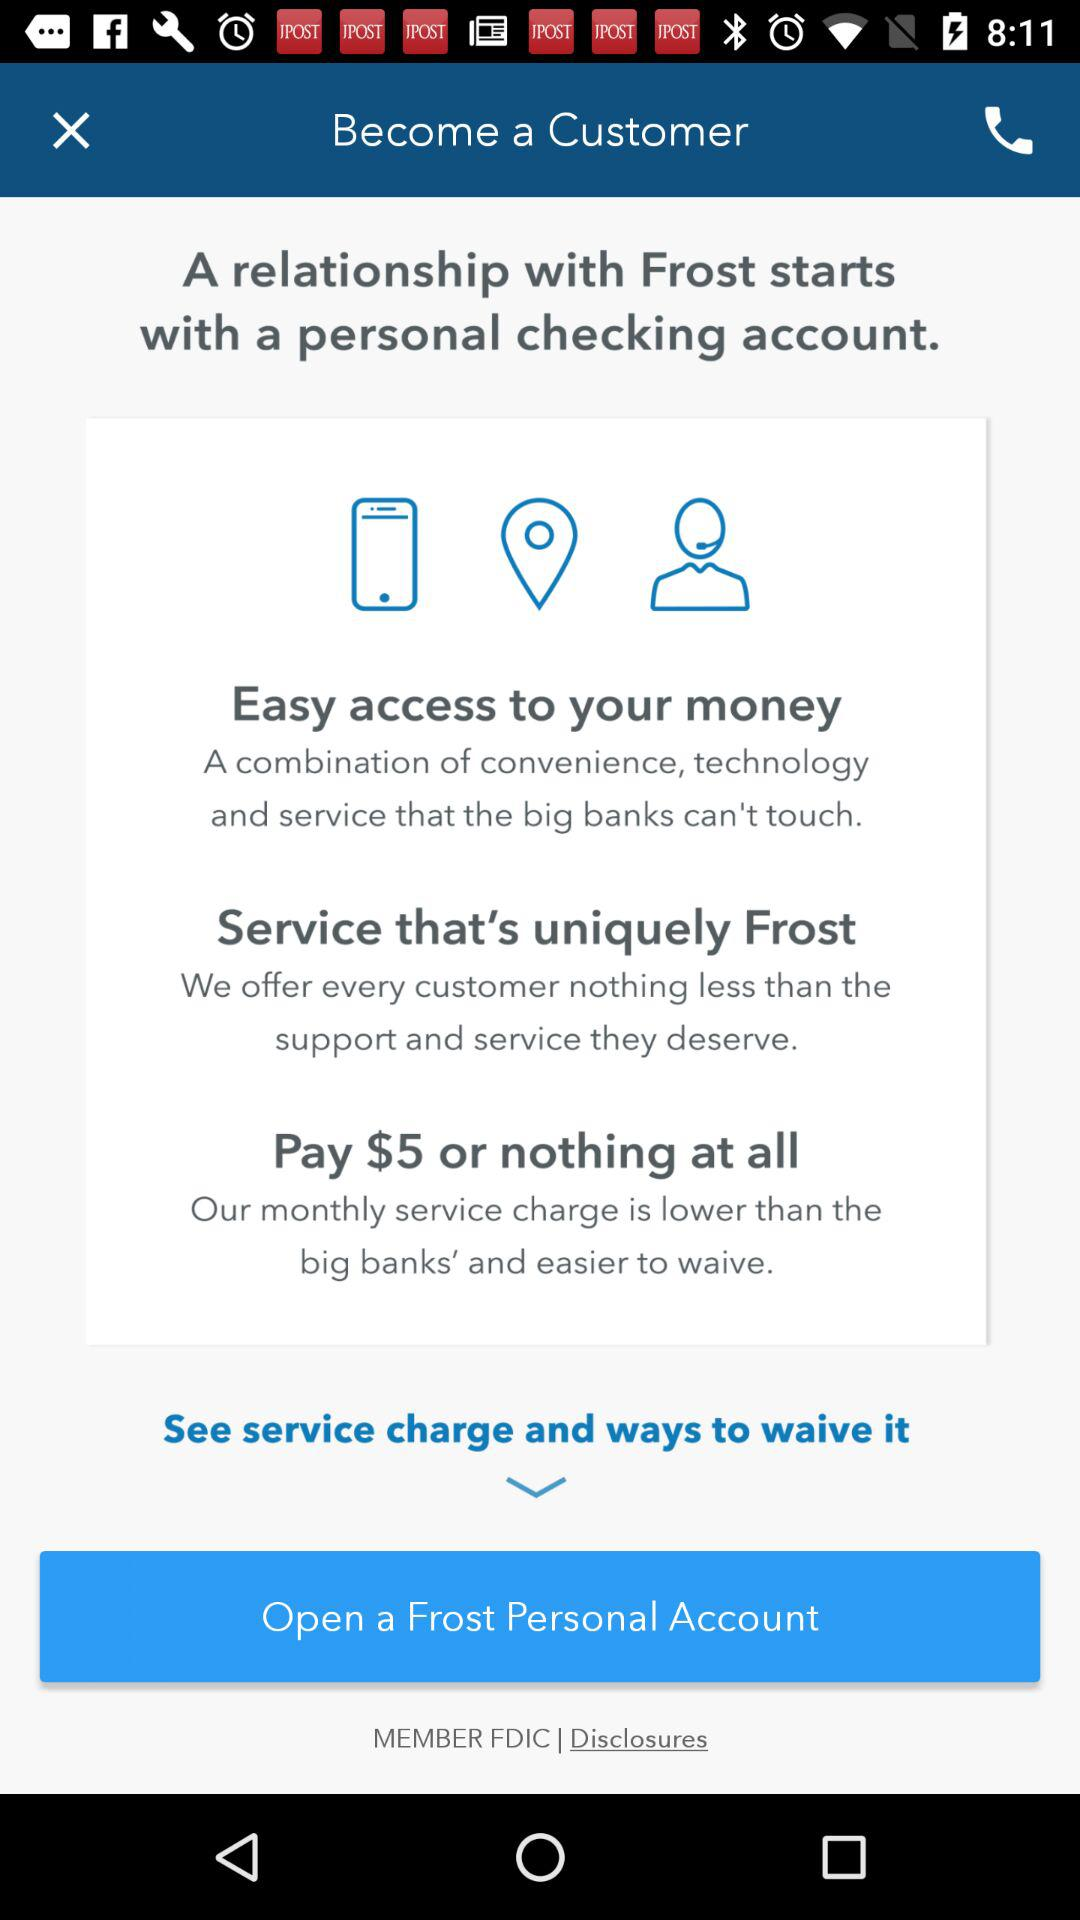How much should be paid to the bank as monthly service charges? Monthly service charges of $5 should be paid to the bank. 